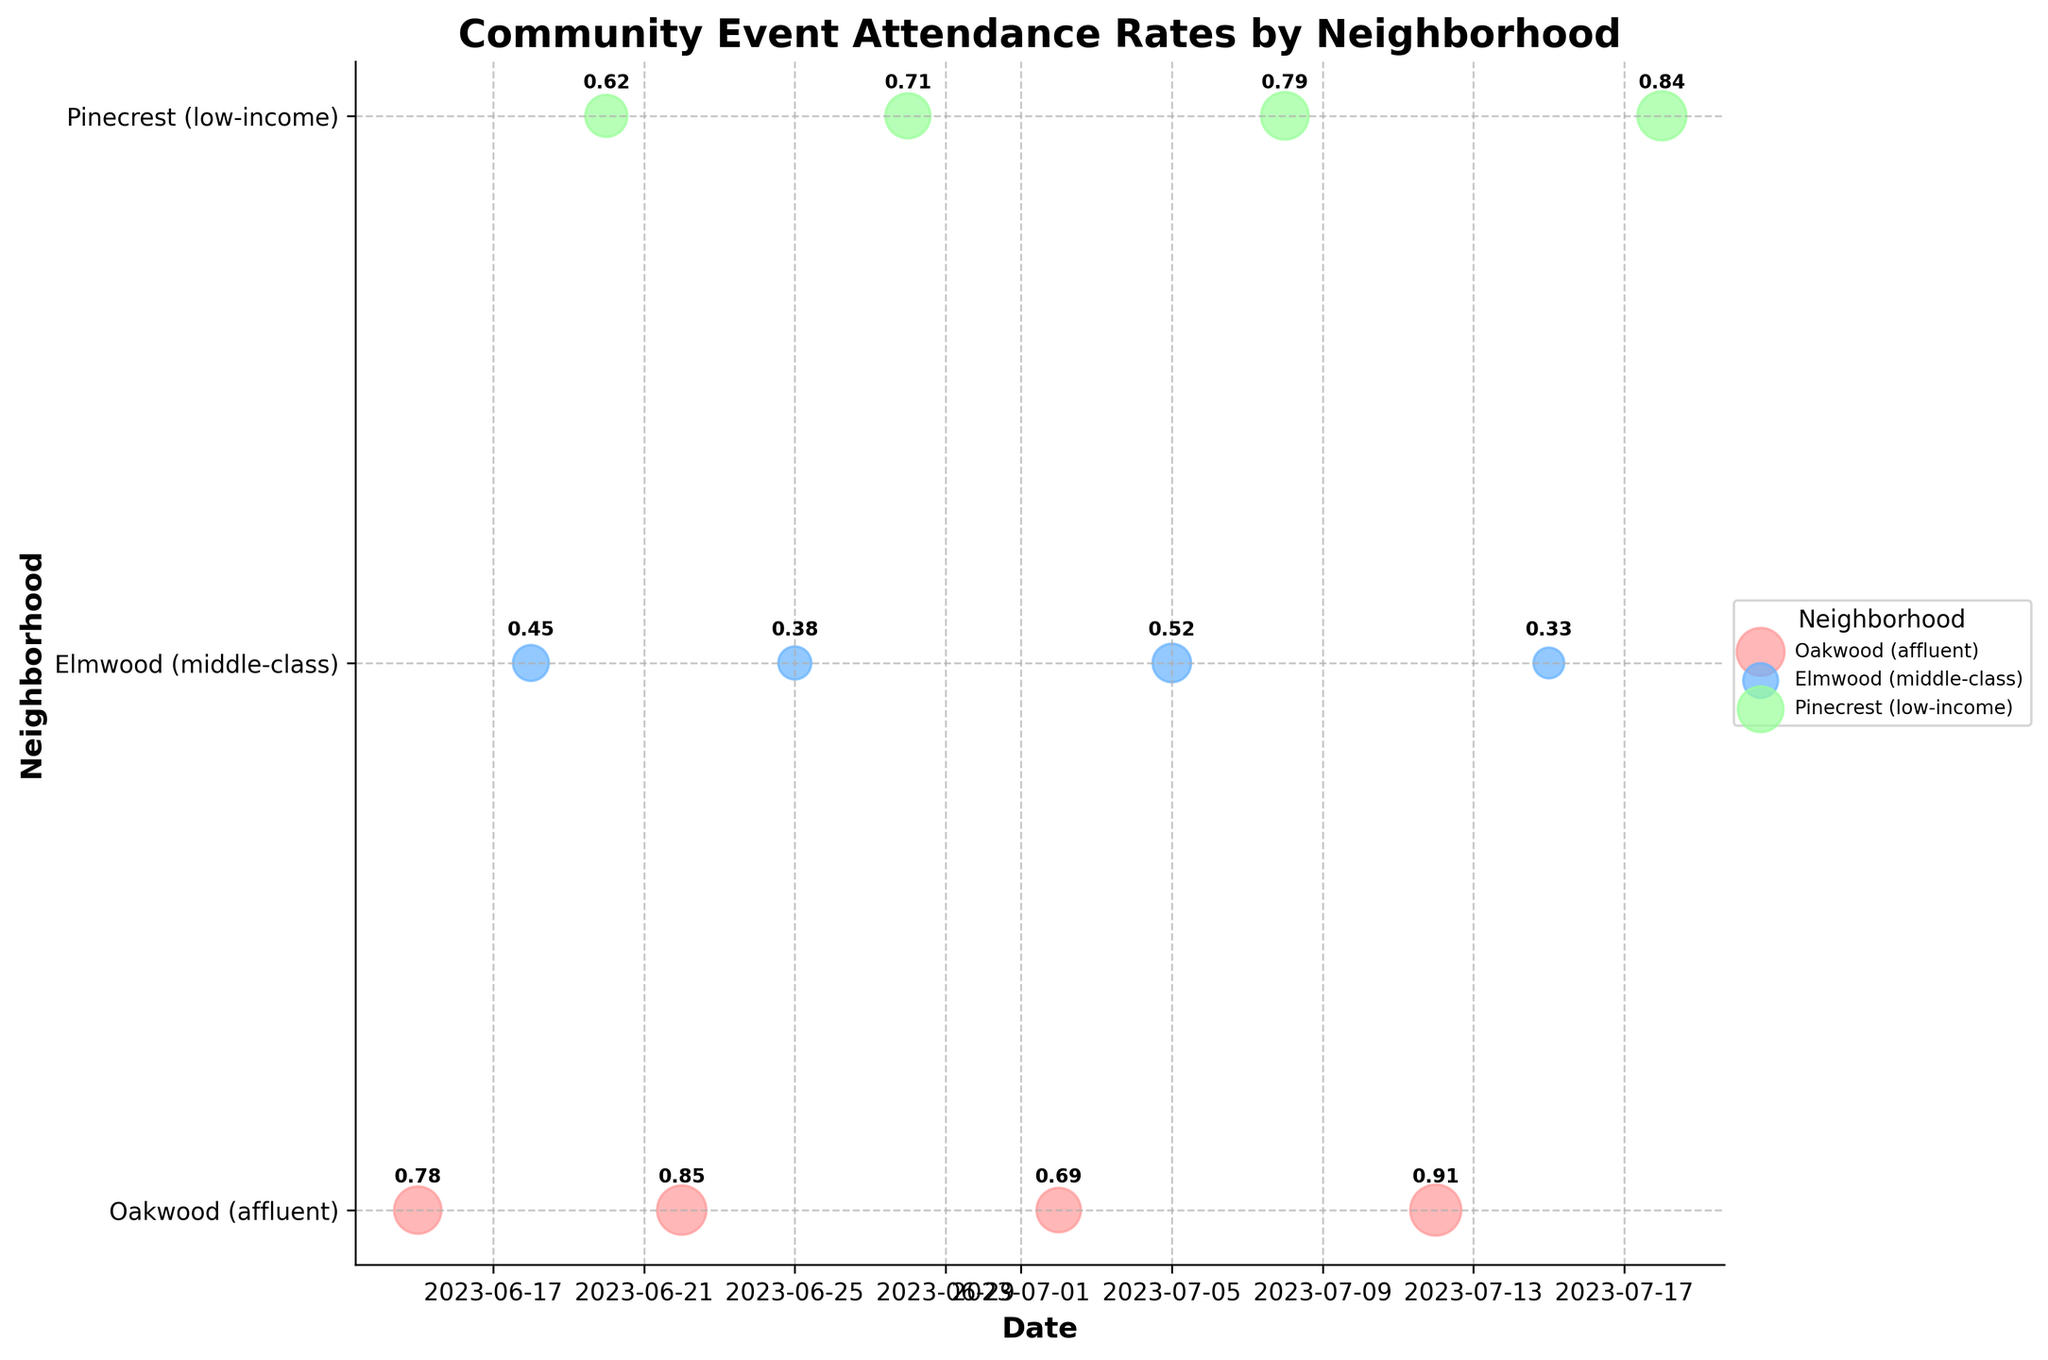What is the title of the figure? The title is typically placed at the top of the figure and is designed to explain what the chart represents.
Answer: Community Event Attendance Rates by Neighborhood How many neighborhoods are represented in the figure? The labels on the y-axis indicate different neighborhoods. Count the unique labels shown.
Answer: 3 What neighborhood had the highest attendance rate and for which event? Look at the sizes of the circles indicating event attendance rates. Identify the largest circle and the associated event and neighborhood.
Answer: Oakwood (affluent), Music Festival Which neighborhood had the most events? Count the number of circles (events) for each neighborhood on the y-axis. The neighborhood with the most circles has the most events.
Answer: Pinecrest (low-income) and Oakwood (affluent) (tied) What is the average attendance rate for events in Elmwood (middle-class)? Identify all attendance rates in Elmwood, sum them, and divide by the number of events in Elmwood.
Answer: (0.45 + 0.38 + 0.52 + 0.33) / 4 = 0.42 Which event in Pinecrest had the lowest attendance rate? Locate the smallest circle along the y-axis labeled Pinecrest and identify the corresponding event.
Answer: Street Fair Compare the attendance rate for the Farmers Market in Oakwood and the Town Hall Meeting in Elmwood. Which was higher? Locate both events on the plot and compare the sizes of the circles or annotated rates.
Answer: Farmers Market in Oakwood On which date did Elmwood (middle-class) host the Community Clean-up event? Check the x-axis location of the Community Clean-up event in the Elmwood row.
Answer: 2023-07-05 How did the attendance rate for the Job Fair in Pinecrest compare to the Food Drive in the same neighborhood? Compare the annotated attendance rates for both events in Pinecrest.
Answer: Job Fair (0.71) was lower than Food Drive (0.79) Which event had an attendance rate of 0.78 in Oakwood? Find the circle with the corresponding size or annotation of 0.78 in the Oakwood row.
Answer: Community Picnic 